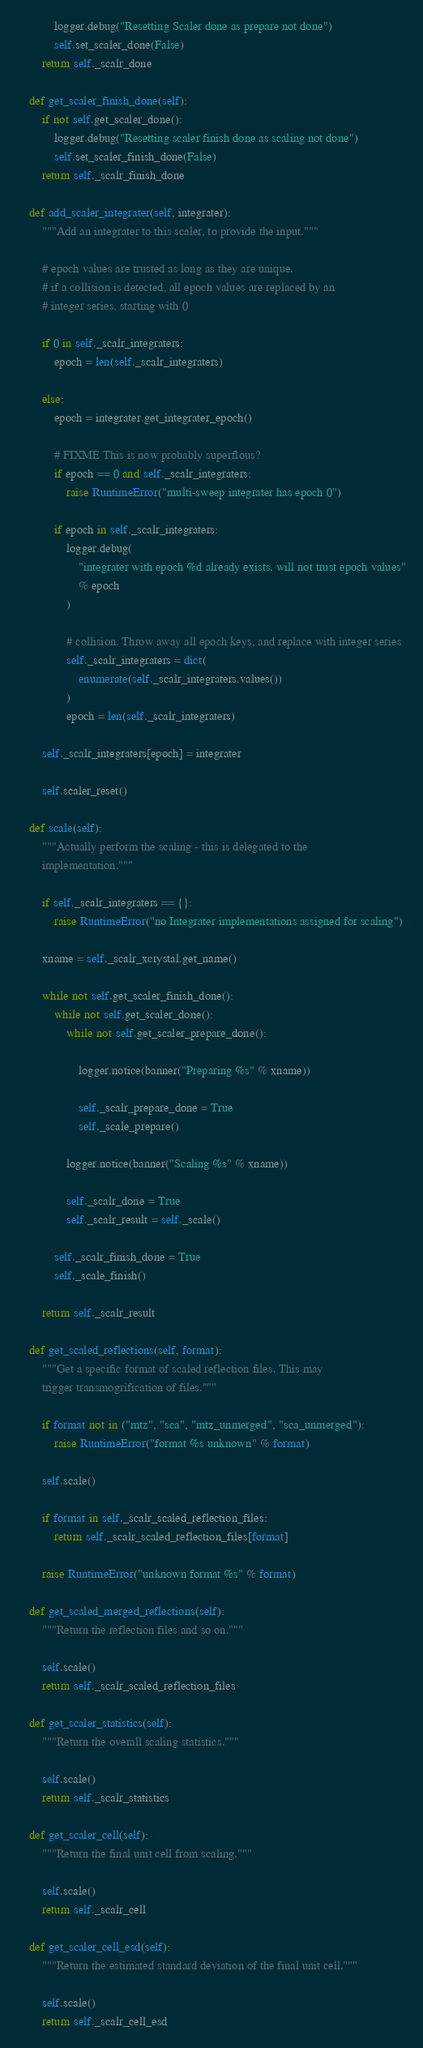Convert code to text. <code><loc_0><loc_0><loc_500><loc_500><_Python_>            logger.debug("Resetting Scaler done as prepare not done")
            self.set_scaler_done(False)
        return self._scalr_done

    def get_scaler_finish_done(self):
        if not self.get_scaler_done():
            logger.debug("Resetting scaler finish done as scaling not done")
            self.set_scaler_finish_done(False)
        return self._scalr_finish_done

    def add_scaler_integrater(self, integrater):
        """Add an integrater to this scaler, to provide the input."""

        # epoch values are trusted as long as they are unique.
        # if a collision is detected, all epoch values are replaced by an
        # integer series, starting with 0

        if 0 in self._scalr_integraters:
            epoch = len(self._scalr_integraters)

        else:
            epoch = integrater.get_integrater_epoch()

            # FIXME This is now probably superflous?
            if epoch == 0 and self._scalr_integraters:
                raise RuntimeError("multi-sweep integrater has epoch 0")

            if epoch in self._scalr_integraters:
                logger.debug(
                    "integrater with epoch %d already exists. will not trust epoch values"
                    % epoch
                )

                # collision. Throw away all epoch keys, and replace with integer series
                self._scalr_integraters = dict(
                    enumerate(self._scalr_integraters.values())
                )
                epoch = len(self._scalr_integraters)

        self._scalr_integraters[epoch] = integrater

        self.scaler_reset()

    def scale(self):
        """Actually perform the scaling - this is delegated to the
        implementation."""

        if self._scalr_integraters == {}:
            raise RuntimeError("no Integrater implementations assigned for scaling")

        xname = self._scalr_xcrystal.get_name()

        while not self.get_scaler_finish_done():
            while not self.get_scaler_done():
                while not self.get_scaler_prepare_done():

                    logger.notice(banner("Preparing %s" % xname))

                    self._scalr_prepare_done = True
                    self._scale_prepare()

                logger.notice(banner("Scaling %s" % xname))

                self._scalr_done = True
                self._scalr_result = self._scale()

            self._scalr_finish_done = True
            self._scale_finish()

        return self._scalr_result

    def get_scaled_reflections(self, format):
        """Get a specific format of scaled reflection files. This may
        trigger transmogrification of files."""

        if format not in ("mtz", "sca", "mtz_unmerged", "sca_unmerged"):
            raise RuntimeError("format %s unknown" % format)

        self.scale()

        if format in self._scalr_scaled_reflection_files:
            return self._scalr_scaled_reflection_files[format]

        raise RuntimeError("unknown format %s" % format)

    def get_scaled_merged_reflections(self):
        """Return the reflection files and so on."""

        self.scale()
        return self._scalr_scaled_reflection_files

    def get_scaler_statistics(self):
        """Return the overall scaling statistics."""

        self.scale()
        return self._scalr_statistics

    def get_scaler_cell(self):
        """Return the final unit cell from scaling."""

        self.scale()
        return self._scalr_cell

    def get_scaler_cell_esd(self):
        """Return the estimated standard deviation of the final unit cell."""

        self.scale()
        return self._scalr_cell_esd
</code> 